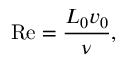<formula> <loc_0><loc_0><loc_500><loc_500>R e = \frac { L _ { 0 } v _ { 0 } } { \nu } ,</formula> 